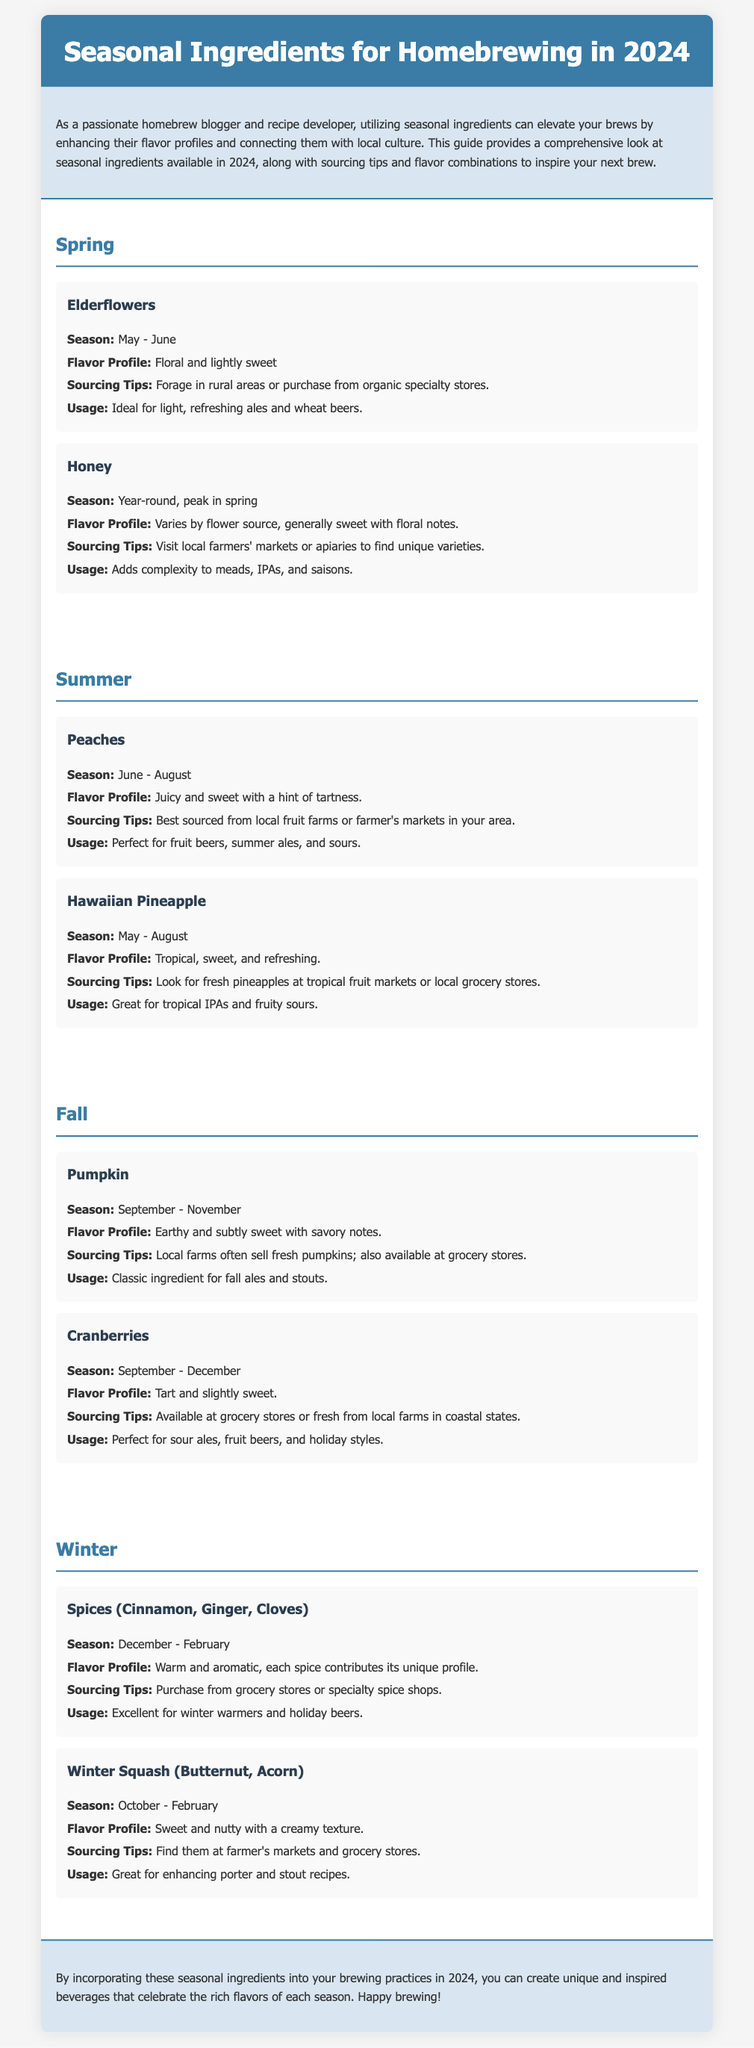What is the title of the guide? The title is prominently displayed at the top of the document, indicating the main focus of the content.
Answer: Seasonal Ingredients for Homebrewing in 2024 What is the flavor profile of elderflowers? The flavor profile section for elderflowers provides a descriptive taste characteristic.
Answer: Floral and lightly sweet When are peaches in season? The document specifies the season for peaches, which is indicated within the relevant section.
Answer: June - August Which two ingredients are recommended for winter brewing? A specific section details winter ingredients for homebrewing; therefore, this question focuses on that.
Answer: Spices (Cinnamon, Ginger, Cloves) and Winter Squash (Butternut, Acorn) What is the main usage for cranberries in brewing? The document outlines the ideal usage for cranberries, providing context for their flavor.
Answer: Perfect for sour ales, fruit beers, and holiday styles What sourcing tips are given for honey? The sourcing tips provide practical advice on where to find honey, emphasizing local options.
Answer: Visit local farmers' markets or apiaries to find unique varieties Which ingredient is described as "juicy and sweet"? The flavor description directly correlates to one of the ingredients listed in the summer section.
Answer: Peaches How can incorporating seasonal ingredients benefit homebrewers? The introduction highlights the advantages of using seasonal ingredients in brewing.
Answer: Enhancing their flavor profiles and connecting them with local culture 